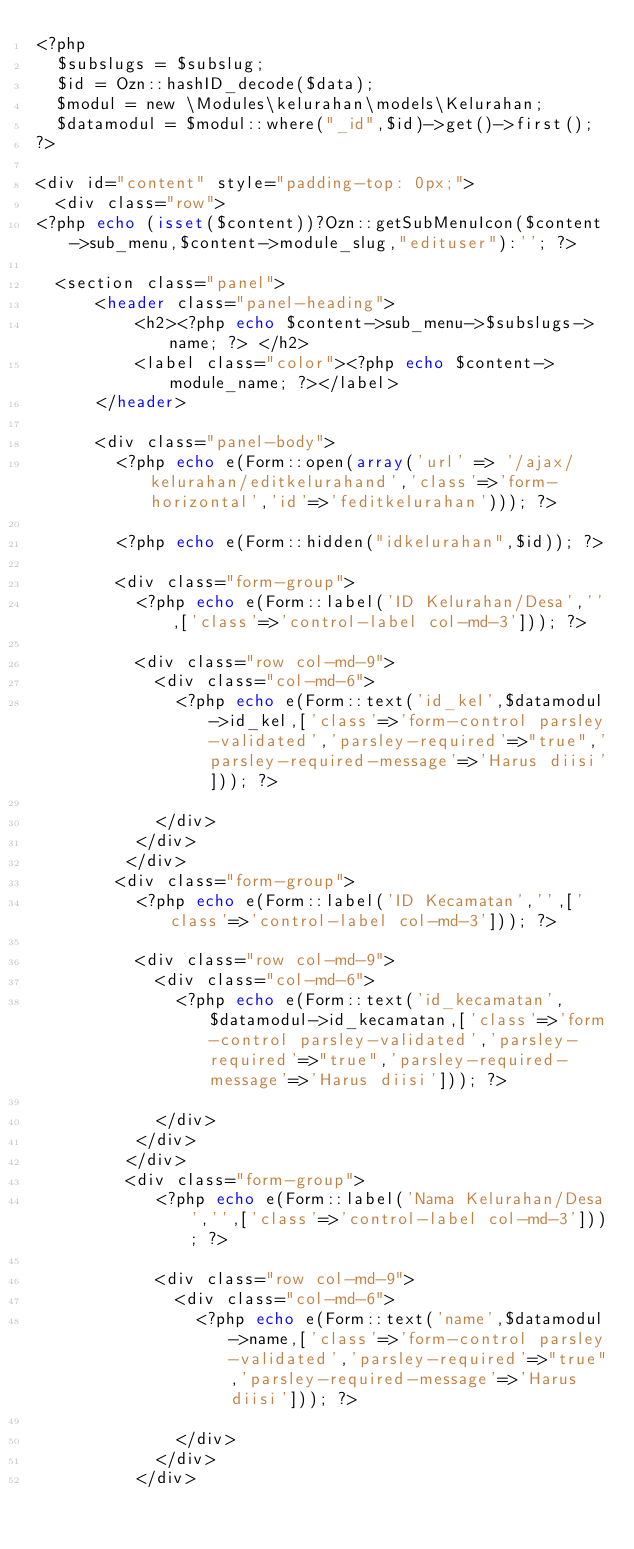Convert code to text. <code><loc_0><loc_0><loc_500><loc_500><_PHP_><?php
	$subslugs = $subslug;
	$id = Ozn::hashID_decode($data);
	$modul = new \Modules\kelurahan\models\Kelurahan;
	$datamodul = $modul::where("_id",$id)->get()->first();
?>

<div id="content" style="padding-top: 0px;">
	<div class="row">
<?php echo (isset($content))?Ozn::getSubMenuIcon($content->sub_menu,$content->module_slug,"edituser"):''; ?>

	<section class="panel">
			<header class="panel-heading">
					<h2><?php echo $content->sub_menu->$subslugs->name; ?> </h2>
					<label class="color"><?php echo $content->module_name; ?></label>
			</header>

			<div class="panel-body">
				<?php echo e(Form::open(array('url' => '/ajax/kelurahan/editkelurahand','class'=>'form-horizontal','id'=>'feditkelurahan'))); ?>

				<?php echo e(Form::hidden("idkelurahan",$id)); ?>

				<div class="form-group">
					<?php echo e(Form::label('ID Kelurahan/Desa','',['class'=>'control-label col-md-3'])); ?>

					<div class="row col-md-9">
						<div class="col-md-6">
							<?php echo e(Form::text('id_kel',$datamodul->id_kel,['class'=>'form-control parsley-validated','parsley-required'=>"true",'parsley-required-message'=>'Harus diisi'])); ?>

						</div>
					</div>
				 </div>
				<div class="form-group">
					<?php echo e(Form::label('ID Kecamatan','',['class'=>'control-label col-md-3'])); ?>

					<div class="row col-md-9">
						<div class="col-md-6">
							<?php echo e(Form::text('id_kecamatan',$datamodul->id_kecamatan,['class'=>'form-control parsley-validated','parsley-required'=>"true",'parsley-required-message'=>'Harus diisi'])); ?>

						</div>
					</div>
				 </div>
				 <div class="form-group">
						<?php echo e(Form::label('Nama Kelurahan/Desa','',['class'=>'control-label col-md-3'])); ?>

						<div class="row col-md-9">
							<div class="col-md-6">
								<?php echo e(Form::text('name',$datamodul->name,['class'=>'form-control parsley-validated','parsley-required'=>"true",'parsley-required-message'=>'Harus diisi'])); ?>

							</div>
						</div>
					</div>
</code> 